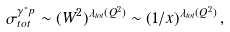<formula> <loc_0><loc_0><loc_500><loc_500>\sigma _ { t o t } ^ { \gamma ^ { * } p } \sim ( W ^ { 2 } ) ^ { \lambda _ { t o t } ( Q ^ { 2 } ) } \sim ( 1 / x ) ^ { \lambda _ { t o t } ( Q ^ { 2 } ) } \, ,</formula> 